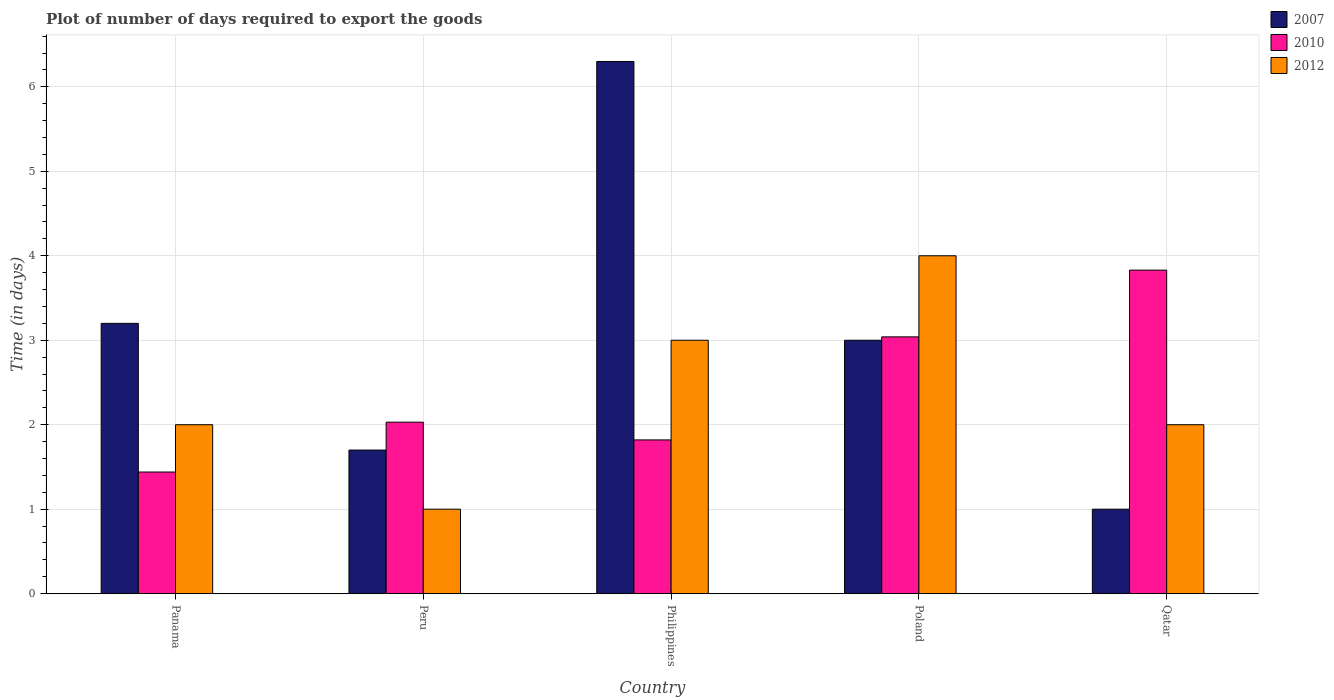How many different coloured bars are there?
Keep it short and to the point. 3. How many groups of bars are there?
Your response must be concise. 5. Are the number of bars per tick equal to the number of legend labels?
Ensure brevity in your answer.  Yes. Are the number of bars on each tick of the X-axis equal?
Keep it short and to the point. Yes. How many bars are there on the 4th tick from the left?
Your answer should be very brief. 3. In how many cases, is the number of bars for a given country not equal to the number of legend labels?
Your response must be concise. 0. Across all countries, what is the maximum time required to export goods in 2007?
Provide a short and direct response. 6.3. Across all countries, what is the minimum time required to export goods in 2010?
Your answer should be compact. 1.44. In which country was the time required to export goods in 2007 maximum?
Your answer should be very brief. Philippines. In which country was the time required to export goods in 2007 minimum?
Offer a terse response. Qatar. What is the total time required to export goods in 2010 in the graph?
Offer a very short reply. 12.16. What is the difference between the time required to export goods in 2007 in Panama and that in Poland?
Offer a terse response. 0.2. What is the difference between the time required to export goods in 2012 in Peru and the time required to export goods in 2010 in Philippines?
Your response must be concise. -0.82. What is the average time required to export goods in 2007 per country?
Your answer should be compact. 3.04. What is the difference between the time required to export goods of/in 2007 and time required to export goods of/in 2010 in Qatar?
Give a very brief answer. -2.83. In how many countries, is the time required to export goods in 2007 greater than 3 days?
Provide a succinct answer. 2. What is the ratio of the time required to export goods in 2012 in Panama to that in Philippines?
Provide a short and direct response. 0.67. Is the time required to export goods in 2007 in Peru less than that in Philippines?
Keep it short and to the point. Yes. What is the difference between the highest and the second highest time required to export goods in 2010?
Your answer should be compact. 1.01. What is the difference between the highest and the lowest time required to export goods in 2010?
Offer a terse response. 2.39. In how many countries, is the time required to export goods in 2007 greater than the average time required to export goods in 2007 taken over all countries?
Ensure brevity in your answer.  2. What does the 2nd bar from the right in Peru represents?
Your answer should be very brief. 2010. Are all the bars in the graph horizontal?
Provide a succinct answer. No. Are the values on the major ticks of Y-axis written in scientific E-notation?
Your answer should be compact. No. Does the graph contain grids?
Offer a very short reply. Yes. Where does the legend appear in the graph?
Your answer should be compact. Top right. What is the title of the graph?
Provide a short and direct response. Plot of number of days required to export the goods. Does "2005" appear as one of the legend labels in the graph?
Your answer should be very brief. No. What is the label or title of the X-axis?
Provide a short and direct response. Country. What is the label or title of the Y-axis?
Your answer should be very brief. Time (in days). What is the Time (in days) of 2010 in Panama?
Ensure brevity in your answer.  1.44. What is the Time (in days) of 2010 in Peru?
Your response must be concise. 2.03. What is the Time (in days) in 2010 in Philippines?
Your answer should be very brief. 1.82. What is the Time (in days) in 2012 in Philippines?
Your response must be concise. 3. What is the Time (in days) in 2010 in Poland?
Provide a short and direct response. 3.04. What is the Time (in days) of 2012 in Poland?
Offer a very short reply. 4. What is the Time (in days) in 2010 in Qatar?
Offer a very short reply. 3.83. What is the Time (in days) in 2012 in Qatar?
Provide a succinct answer. 2. Across all countries, what is the maximum Time (in days) in 2007?
Your answer should be very brief. 6.3. Across all countries, what is the maximum Time (in days) in 2010?
Keep it short and to the point. 3.83. Across all countries, what is the maximum Time (in days) of 2012?
Give a very brief answer. 4. Across all countries, what is the minimum Time (in days) in 2007?
Give a very brief answer. 1. Across all countries, what is the minimum Time (in days) in 2010?
Provide a succinct answer. 1.44. Across all countries, what is the minimum Time (in days) of 2012?
Provide a succinct answer. 1. What is the total Time (in days) of 2010 in the graph?
Provide a short and direct response. 12.16. What is the difference between the Time (in days) in 2010 in Panama and that in Peru?
Offer a terse response. -0.59. What is the difference between the Time (in days) of 2012 in Panama and that in Peru?
Ensure brevity in your answer.  1. What is the difference between the Time (in days) in 2007 in Panama and that in Philippines?
Your answer should be compact. -3.1. What is the difference between the Time (in days) in 2010 in Panama and that in Philippines?
Offer a very short reply. -0.38. What is the difference between the Time (in days) of 2012 in Panama and that in Poland?
Provide a succinct answer. -2. What is the difference between the Time (in days) in 2010 in Panama and that in Qatar?
Keep it short and to the point. -2.39. What is the difference between the Time (in days) of 2007 in Peru and that in Philippines?
Provide a succinct answer. -4.6. What is the difference between the Time (in days) of 2010 in Peru and that in Philippines?
Give a very brief answer. 0.21. What is the difference between the Time (in days) of 2012 in Peru and that in Philippines?
Your response must be concise. -2. What is the difference between the Time (in days) in 2007 in Peru and that in Poland?
Offer a terse response. -1.3. What is the difference between the Time (in days) of 2010 in Peru and that in Poland?
Give a very brief answer. -1.01. What is the difference between the Time (in days) of 2012 in Peru and that in Poland?
Your answer should be compact. -3. What is the difference between the Time (in days) in 2007 in Peru and that in Qatar?
Offer a very short reply. 0.7. What is the difference between the Time (in days) of 2007 in Philippines and that in Poland?
Provide a short and direct response. 3.3. What is the difference between the Time (in days) in 2010 in Philippines and that in Poland?
Keep it short and to the point. -1.22. What is the difference between the Time (in days) in 2012 in Philippines and that in Poland?
Your answer should be very brief. -1. What is the difference between the Time (in days) in 2007 in Philippines and that in Qatar?
Ensure brevity in your answer.  5.3. What is the difference between the Time (in days) in 2010 in Philippines and that in Qatar?
Your response must be concise. -2.01. What is the difference between the Time (in days) in 2012 in Philippines and that in Qatar?
Ensure brevity in your answer.  1. What is the difference between the Time (in days) in 2010 in Poland and that in Qatar?
Give a very brief answer. -0.79. What is the difference between the Time (in days) of 2007 in Panama and the Time (in days) of 2010 in Peru?
Offer a terse response. 1.17. What is the difference between the Time (in days) in 2010 in Panama and the Time (in days) in 2012 in Peru?
Offer a terse response. 0.44. What is the difference between the Time (in days) in 2007 in Panama and the Time (in days) in 2010 in Philippines?
Give a very brief answer. 1.38. What is the difference between the Time (in days) of 2007 in Panama and the Time (in days) of 2012 in Philippines?
Your response must be concise. 0.2. What is the difference between the Time (in days) in 2010 in Panama and the Time (in days) in 2012 in Philippines?
Ensure brevity in your answer.  -1.56. What is the difference between the Time (in days) of 2007 in Panama and the Time (in days) of 2010 in Poland?
Offer a terse response. 0.16. What is the difference between the Time (in days) in 2010 in Panama and the Time (in days) in 2012 in Poland?
Offer a very short reply. -2.56. What is the difference between the Time (in days) of 2007 in Panama and the Time (in days) of 2010 in Qatar?
Give a very brief answer. -0.63. What is the difference between the Time (in days) of 2010 in Panama and the Time (in days) of 2012 in Qatar?
Offer a terse response. -0.56. What is the difference between the Time (in days) in 2007 in Peru and the Time (in days) in 2010 in Philippines?
Make the answer very short. -0.12. What is the difference between the Time (in days) of 2007 in Peru and the Time (in days) of 2012 in Philippines?
Provide a short and direct response. -1.3. What is the difference between the Time (in days) of 2010 in Peru and the Time (in days) of 2012 in Philippines?
Keep it short and to the point. -0.97. What is the difference between the Time (in days) in 2007 in Peru and the Time (in days) in 2010 in Poland?
Ensure brevity in your answer.  -1.34. What is the difference between the Time (in days) in 2010 in Peru and the Time (in days) in 2012 in Poland?
Your answer should be very brief. -1.97. What is the difference between the Time (in days) in 2007 in Peru and the Time (in days) in 2010 in Qatar?
Make the answer very short. -2.13. What is the difference between the Time (in days) in 2007 in Peru and the Time (in days) in 2012 in Qatar?
Make the answer very short. -0.3. What is the difference between the Time (in days) of 2007 in Philippines and the Time (in days) of 2010 in Poland?
Your answer should be very brief. 3.26. What is the difference between the Time (in days) in 2010 in Philippines and the Time (in days) in 2012 in Poland?
Offer a terse response. -2.18. What is the difference between the Time (in days) in 2007 in Philippines and the Time (in days) in 2010 in Qatar?
Ensure brevity in your answer.  2.47. What is the difference between the Time (in days) of 2010 in Philippines and the Time (in days) of 2012 in Qatar?
Provide a succinct answer. -0.18. What is the difference between the Time (in days) in 2007 in Poland and the Time (in days) in 2010 in Qatar?
Your answer should be compact. -0.83. What is the difference between the Time (in days) in 2007 in Poland and the Time (in days) in 2012 in Qatar?
Your answer should be very brief. 1. What is the average Time (in days) of 2007 per country?
Your response must be concise. 3.04. What is the average Time (in days) of 2010 per country?
Your answer should be compact. 2.43. What is the average Time (in days) of 2012 per country?
Offer a very short reply. 2.4. What is the difference between the Time (in days) of 2007 and Time (in days) of 2010 in Panama?
Provide a short and direct response. 1.76. What is the difference between the Time (in days) in 2010 and Time (in days) in 2012 in Panama?
Your response must be concise. -0.56. What is the difference between the Time (in days) in 2007 and Time (in days) in 2010 in Peru?
Keep it short and to the point. -0.33. What is the difference between the Time (in days) in 2007 and Time (in days) in 2010 in Philippines?
Provide a succinct answer. 4.48. What is the difference between the Time (in days) of 2010 and Time (in days) of 2012 in Philippines?
Give a very brief answer. -1.18. What is the difference between the Time (in days) of 2007 and Time (in days) of 2010 in Poland?
Offer a very short reply. -0.04. What is the difference between the Time (in days) of 2007 and Time (in days) of 2012 in Poland?
Your answer should be compact. -1. What is the difference between the Time (in days) in 2010 and Time (in days) in 2012 in Poland?
Your answer should be compact. -0.96. What is the difference between the Time (in days) of 2007 and Time (in days) of 2010 in Qatar?
Your response must be concise. -2.83. What is the difference between the Time (in days) in 2007 and Time (in days) in 2012 in Qatar?
Give a very brief answer. -1. What is the difference between the Time (in days) of 2010 and Time (in days) of 2012 in Qatar?
Provide a short and direct response. 1.83. What is the ratio of the Time (in days) in 2007 in Panama to that in Peru?
Offer a terse response. 1.88. What is the ratio of the Time (in days) of 2010 in Panama to that in Peru?
Offer a very short reply. 0.71. What is the ratio of the Time (in days) of 2007 in Panama to that in Philippines?
Provide a short and direct response. 0.51. What is the ratio of the Time (in days) of 2010 in Panama to that in Philippines?
Provide a short and direct response. 0.79. What is the ratio of the Time (in days) in 2012 in Panama to that in Philippines?
Provide a short and direct response. 0.67. What is the ratio of the Time (in days) in 2007 in Panama to that in Poland?
Your answer should be very brief. 1.07. What is the ratio of the Time (in days) of 2010 in Panama to that in Poland?
Your answer should be very brief. 0.47. What is the ratio of the Time (in days) in 2012 in Panama to that in Poland?
Your answer should be compact. 0.5. What is the ratio of the Time (in days) in 2007 in Panama to that in Qatar?
Your answer should be compact. 3.2. What is the ratio of the Time (in days) in 2010 in Panama to that in Qatar?
Keep it short and to the point. 0.38. What is the ratio of the Time (in days) in 2007 in Peru to that in Philippines?
Provide a succinct answer. 0.27. What is the ratio of the Time (in days) in 2010 in Peru to that in Philippines?
Your answer should be very brief. 1.12. What is the ratio of the Time (in days) of 2012 in Peru to that in Philippines?
Keep it short and to the point. 0.33. What is the ratio of the Time (in days) in 2007 in Peru to that in Poland?
Give a very brief answer. 0.57. What is the ratio of the Time (in days) in 2010 in Peru to that in Poland?
Your answer should be very brief. 0.67. What is the ratio of the Time (in days) of 2012 in Peru to that in Poland?
Ensure brevity in your answer.  0.25. What is the ratio of the Time (in days) of 2010 in Peru to that in Qatar?
Your response must be concise. 0.53. What is the ratio of the Time (in days) of 2012 in Peru to that in Qatar?
Give a very brief answer. 0.5. What is the ratio of the Time (in days) in 2007 in Philippines to that in Poland?
Provide a succinct answer. 2.1. What is the ratio of the Time (in days) of 2010 in Philippines to that in Poland?
Your answer should be compact. 0.6. What is the ratio of the Time (in days) in 2007 in Philippines to that in Qatar?
Ensure brevity in your answer.  6.3. What is the ratio of the Time (in days) in 2010 in Philippines to that in Qatar?
Provide a short and direct response. 0.48. What is the ratio of the Time (in days) of 2012 in Philippines to that in Qatar?
Your response must be concise. 1.5. What is the ratio of the Time (in days) of 2010 in Poland to that in Qatar?
Offer a terse response. 0.79. What is the difference between the highest and the second highest Time (in days) of 2007?
Offer a terse response. 3.1. What is the difference between the highest and the second highest Time (in days) of 2010?
Your answer should be compact. 0.79. What is the difference between the highest and the lowest Time (in days) in 2007?
Provide a short and direct response. 5.3. What is the difference between the highest and the lowest Time (in days) of 2010?
Offer a terse response. 2.39. 